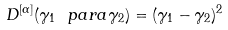Convert formula to latex. <formula><loc_0><loc_0><loc_500><loc_500>D ^ { [ \alpha ] } ( \gamma _ { 1 } \ p a r a \gamma _ { 2 } ) = ( \gamma _ { 1 } - \gamma _ { 2 } ) ^ { 2 }</formula> 